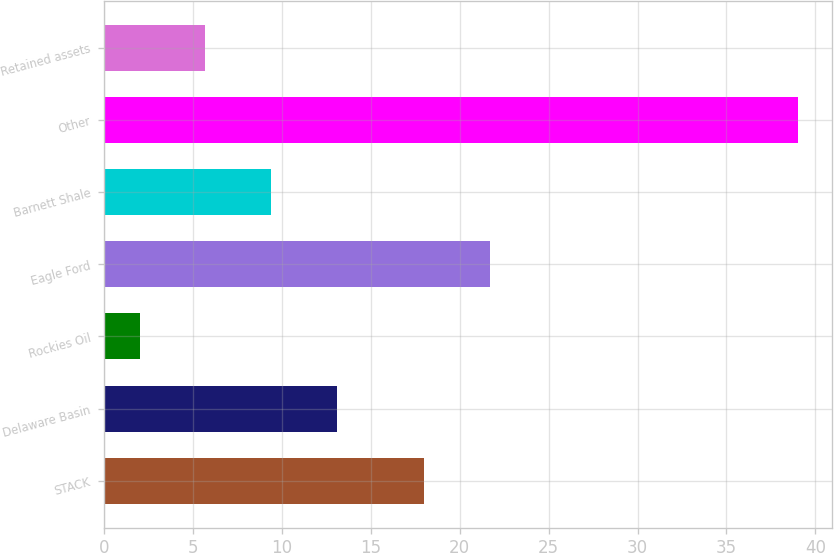Convert chart to OTSL. <chart><loc_0><loc_0><loc_500><loc_500><bar_chart><fcel>STACK<fcel>Delaware Basin<fcel>Rockies Oil<fcel>Eagle Ford<fcel>Barnett Shale<fcel>Other<fcel>Retained assets<nl><fcel>18<fcel>13.1<fcel>2<fcel>21.7<fcel>9.4<fcel>39<fcel>5.7<nl></chart> 